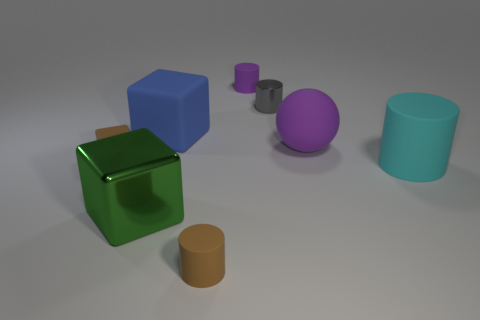Add 2 green balls. How many objects exist? 10 Subtract all small rubber cubes. How many cubes are left? 2 Subtract 1 cylinders. How many cylinders are left? 3 Subtract all blue cubes. How many cubes are left? 2 Subtract all spheres. How many objects are left? 7 Subtract 0 red balls. How many objects are left? 8 Subtract all green cylinders. Subtract all blue cubes. How many cylinders are left? 4 Subtract all red metallic objects. Subtract all large matte cylinders. How many objects are left? 7 Add 2 tiny matte objects. How many tiny matte objects are left? 5 Add 1 cyan matte spheres. How many cyan matte spheres exist? 1 